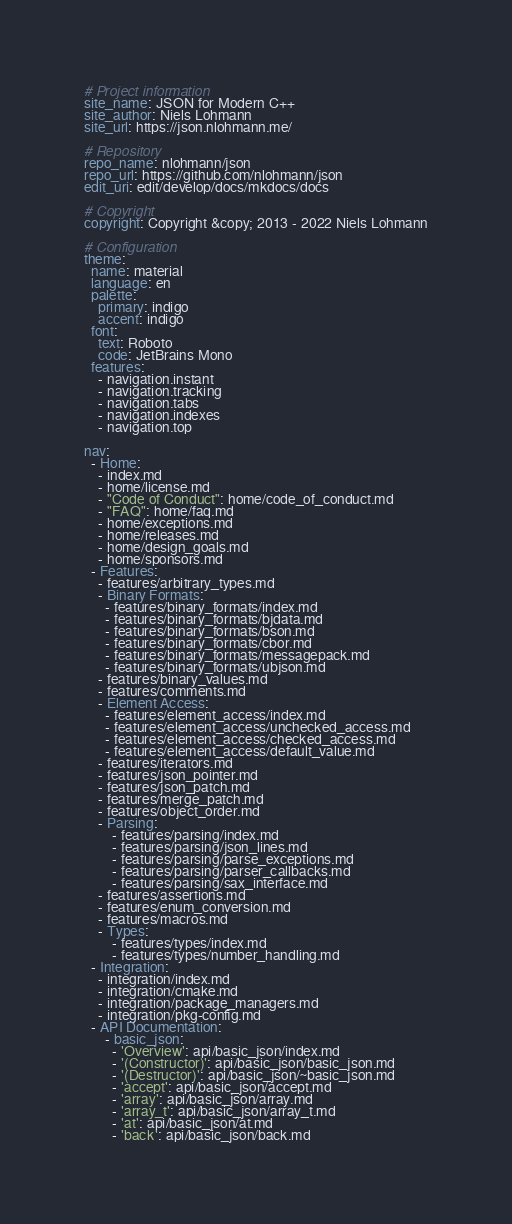Convert code to text. <code><loc_0><loc_0><loc_500><loc_500><_YAML_># Project information
site_name: JSON for Modern C++
site_author: Niels Lohmann
site_url: https://json.nlohmann.me/

# Repository
repo_name: nlohmann/json
repo_url: https://github.com/nlohmann/json
edit_uri: edit/develop/docs/mkdocs/docs

# Copyright
copyright: Copyright &copy; 2013 - 2022 Niels Lohmann

# Configuration
theme:
  name: material
  language: en
  palette:
    primary: indigo
    accent: indigo
  font:
    text: Roboto
    code: JetBrains Mono
  features:
    - navigation.instant
    - navigation.tracking
    - navigation.tabs
    - navigation.indexes
    - navigation.top

nav:
  - Home:
    - index.md
    - home/license.md
    - "Code of Conduct": home/code_of_conduct.md
    - "FAQ": home/faq.md
    - home/exceptions.md
    - home/releases.md
    - home/design_goals.md
    - home/sponsors.md
  - Features:
    - features/arbitrary_types.md
    - Binary Formats:
      - features/binary_formats/index.md
      - features/binary_formats/bjdata.md
      - features/binary_formats/bson.md
      - features/binary_formats/cbor.md
      - features/binary_formats/messagepack.md
      - features/binary_formats/ubjson.md
    - features/binary_values.md
    - features/comments.md
    - Element Access:
      - features/element_access/index.md
      - features/element_access/unchecked_access.md
      - features/element_access/checked_access.md
      - features/element_access/default_value.md
    - features/iterators.md
    - features/json_pointer.md
    - features/json_patch.md
    - features/merge_patch.md
    - features/object_order.md
    - Parsing:
        - features/parsing/index.md
        - features/parsing/json_lines.md
        - features/parsing/parse_exceptions.md
        - features/parsing/parser_callbacks.md
        - features/parsing/sax_interface.md
    - features/assertions.md
    - features/enum_conversion.md
    - features/macros.md
    - Types:
        - features/types/index.md
        - features/types/number_handling.md
  - Integration:
    - integration/index.md
    - integration/cmake.md
    - integration/package_managers.md
    - integration/pkg-config.md
  - API Documentation:
      - basic_json:
        - 'Overview': api/basic_json/index.md
        - '(Constructor)': api/basic_json/basic_json.md
        - '(Destructor)': api/basic_json/~basic_json.md
        - 'accept': api/basic_json/accept.md
        - 'array': api/basic_json/array.md
        - 'array_t': api/basic_json/array_t.md
        - 'at': api/basic_json/at.md
        - 'back': api/basic_json/back.md</code> 